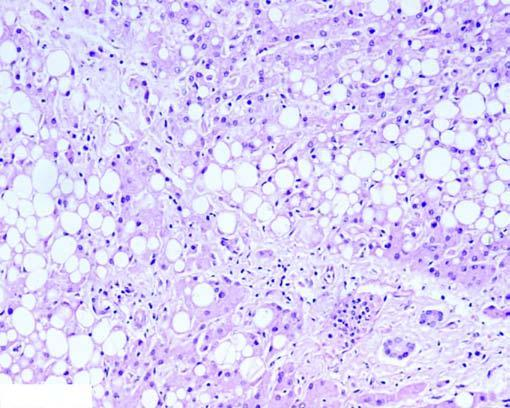what do others show in the cytoplasm (microvesicles)?
Answer the question using a single word or phrase. Multiple small vacuoles 